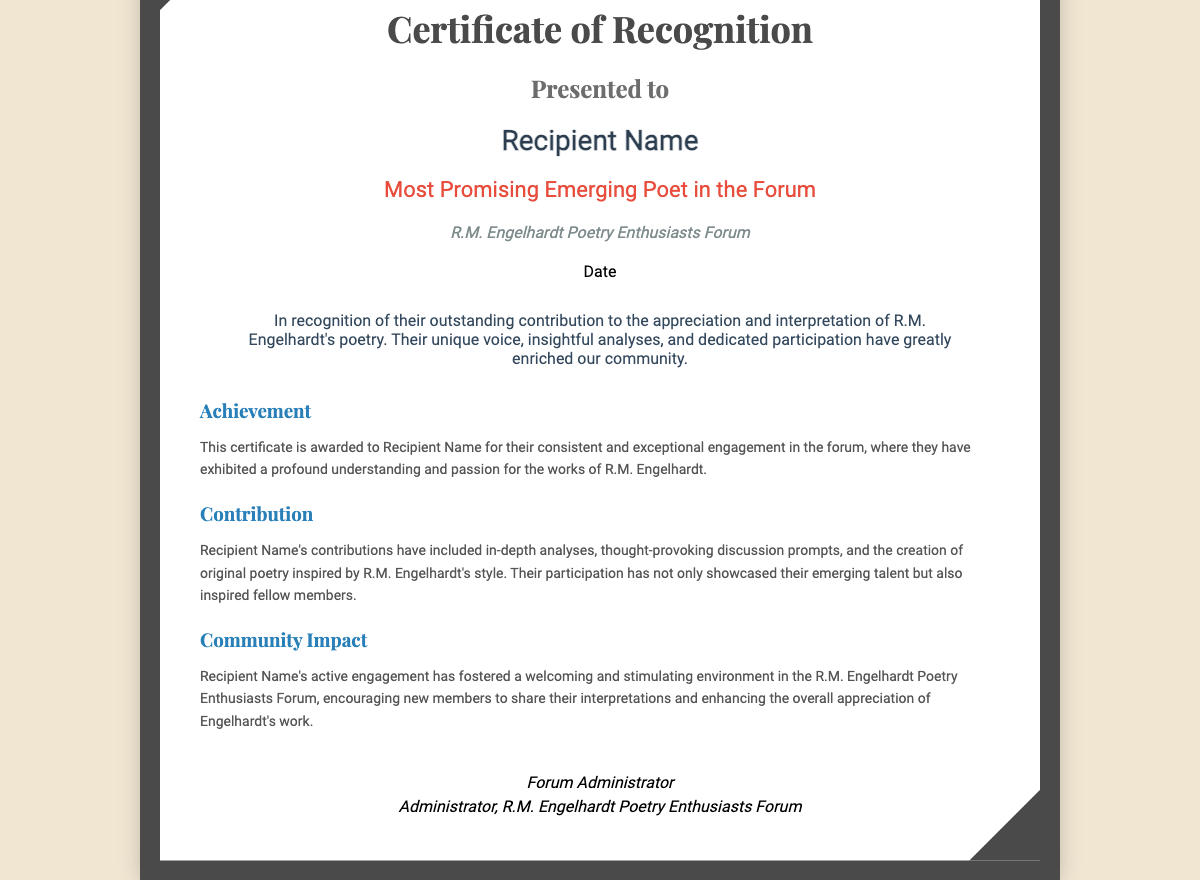what is the title of the certificate? The title is prominently displayed at the top of the document as "Certificate of Recognition."
Answer: Certificate of Recognition who is the recipient of the certificate? The recipient's name is indicated in the designated area where it says "Recipient Name."
Answer: Recipient Name what award is presented in the certificate? The award details are mentioned just below the recipient's name as "Most Promising Emerging Poet in the Forum."
Answer: Most Promising Emerging Poet in the Forum what is the name of the forum? The forum name is explicitly stated under the award as "R.M. Engelhardt Poetry Enthusiasts Forum."
Answer: R.M. Engelhardt Poetry Enthusiasts Forum what date is mentioned in the certificate? The date is specified in a dedicated area labeled simply as "Date."
Answer: Date what is the purpose of the certificate? The document describes its purpose as recognizing outstanding contribution to the appreciation and interpretation of R.M. Engelhardt's poetry.
Answer: Outstanding contribution what are some contributions mentioned for the recipient? Contributions include "in-depth analyses," "thought-provoking discussion prompts," and "the creation of original poetry."
Answer: In-depth analyses, thought-provoking discussion prompts, original poetry who is the signatory on the certificate? The signatory is stated as "Forum Administrator."
Answer: Forum Administrator what impact did the recipient have on the community? The impact is described as fostering a welcoming and stimulating environment in the forum.
Answer: Welcoming and stimulating environment 